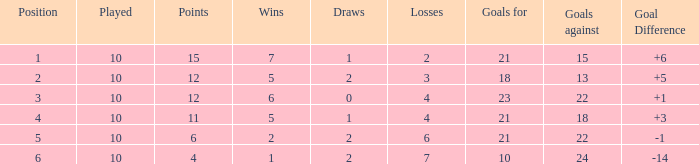Can you tell me the total number of Wins that has the Draws larger than 0, and the Points of 11? 1.0. 